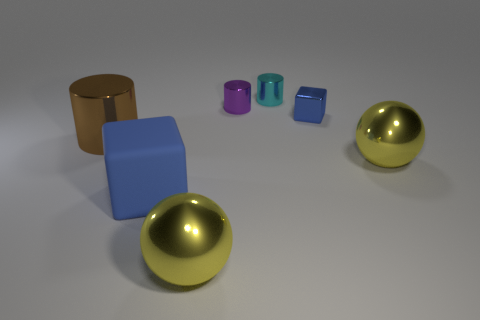What shape is the matte thing that is the same size as the brown metal thing? cube 